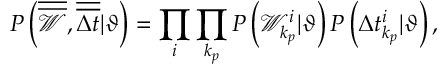<formula> <loc_0><loc_0><loc_500><loc_500>P \left ( \overline { { \overline { { \mathcal { W } } } } } , \overline { { \overline { \Delta t } } } | \vartheta \right ) = \prod _ { i } \prod _ { k _ { p } } P \left ( \mathcal { W } _ { k _ { p } } ^ { i } | \vartheta \right ) P \left ( \Delta t _ { k _ { p } } ^ { i } | \vartheta \right ) ,</formula> 